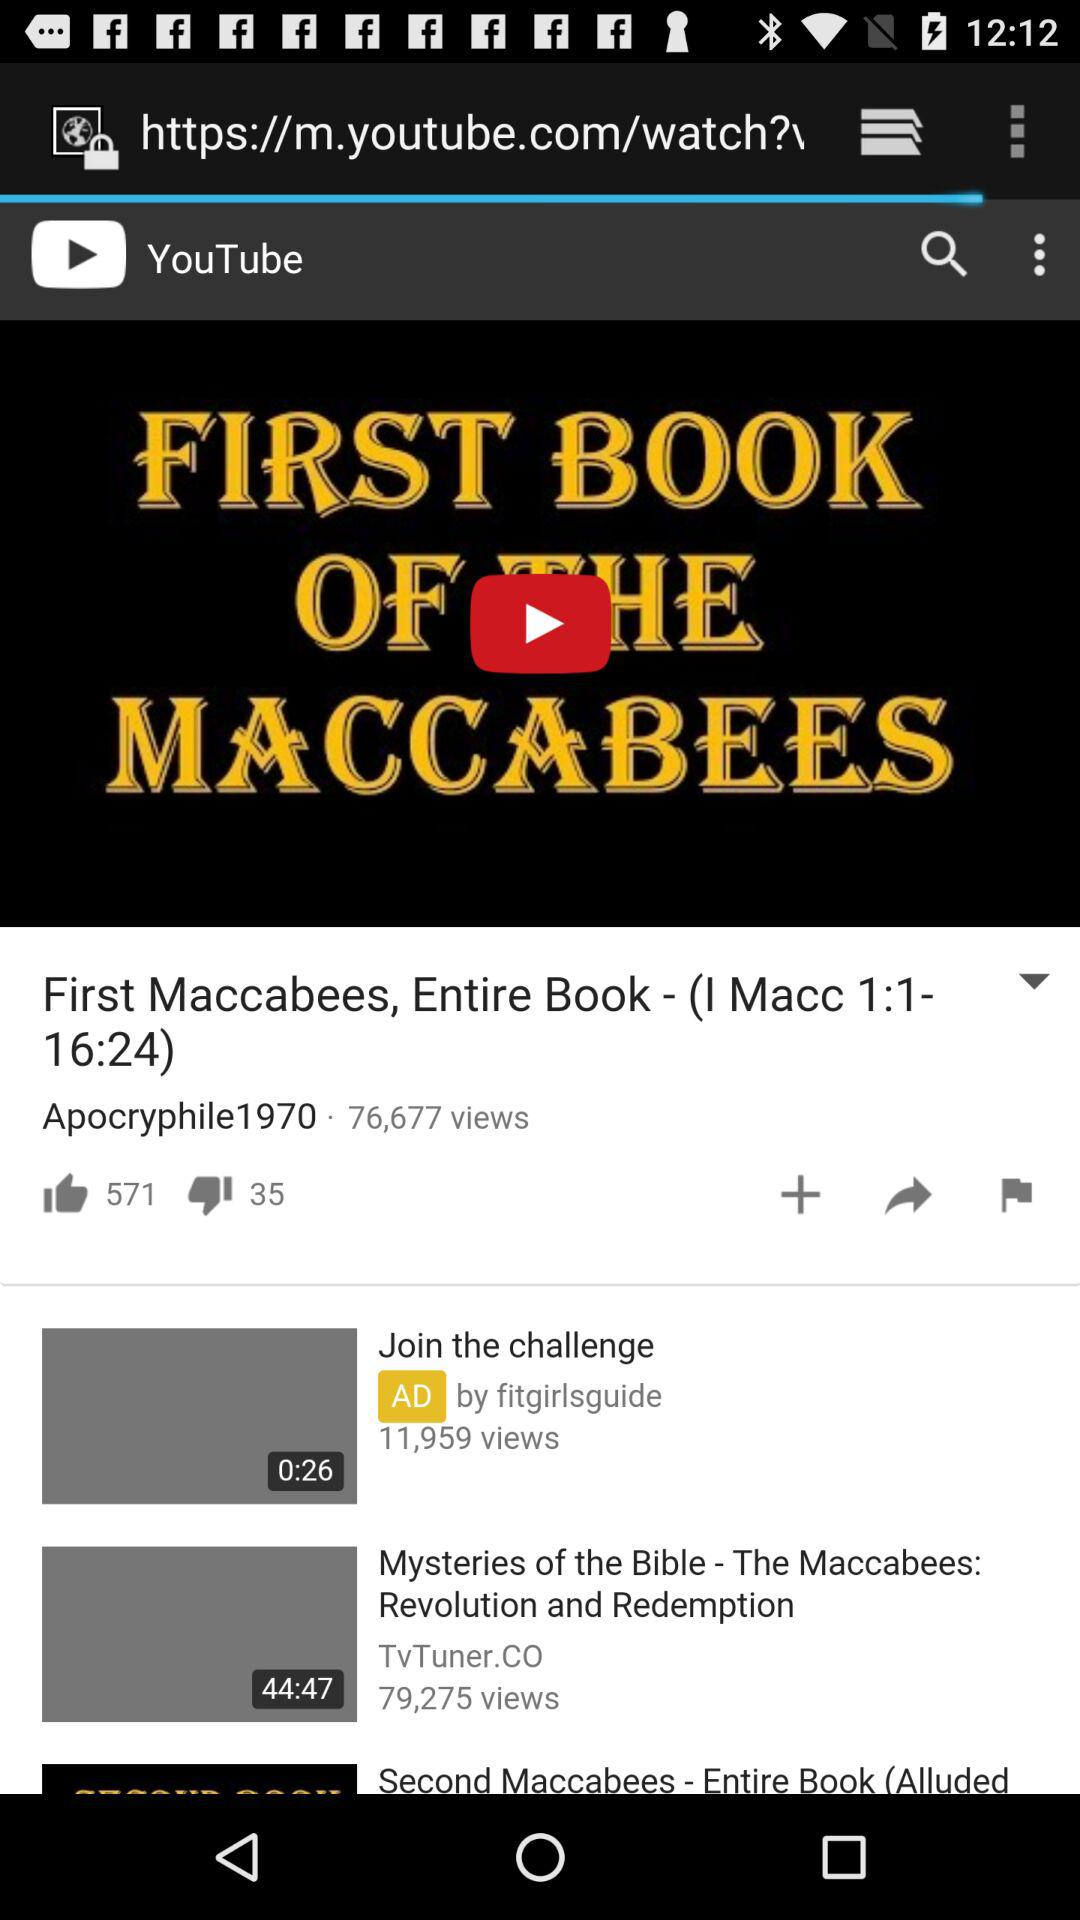What is the duration of the "Join the challenge" video? The duration is 26 seconds. 